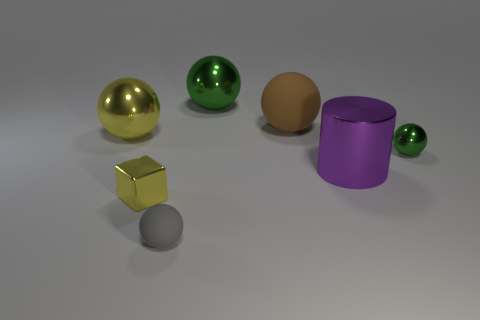Add 1 red shiny things. How many objects exist? 8 Subtract all purple cylinders. How many green spheres are left? 2 Subtract all tiny balls. How many balls are left? 3 Subtract all green spheres. How many spheres are left? 3 Subtract all cubes. How many objects are left? 6 Add 2 big green cylinders. How many big green cylinders exist? 2 Subtract 1 yellow blocks. How many objects are left? 6 Subtract all green cubes. Subtract all gray balls. How many cubes are left? 1 Subtract all large green cylinders. Subtract all tiny yellow blocks. How many objects are left? 6 Add 4 purple shiny things. How many purple shiny things are left? 5 